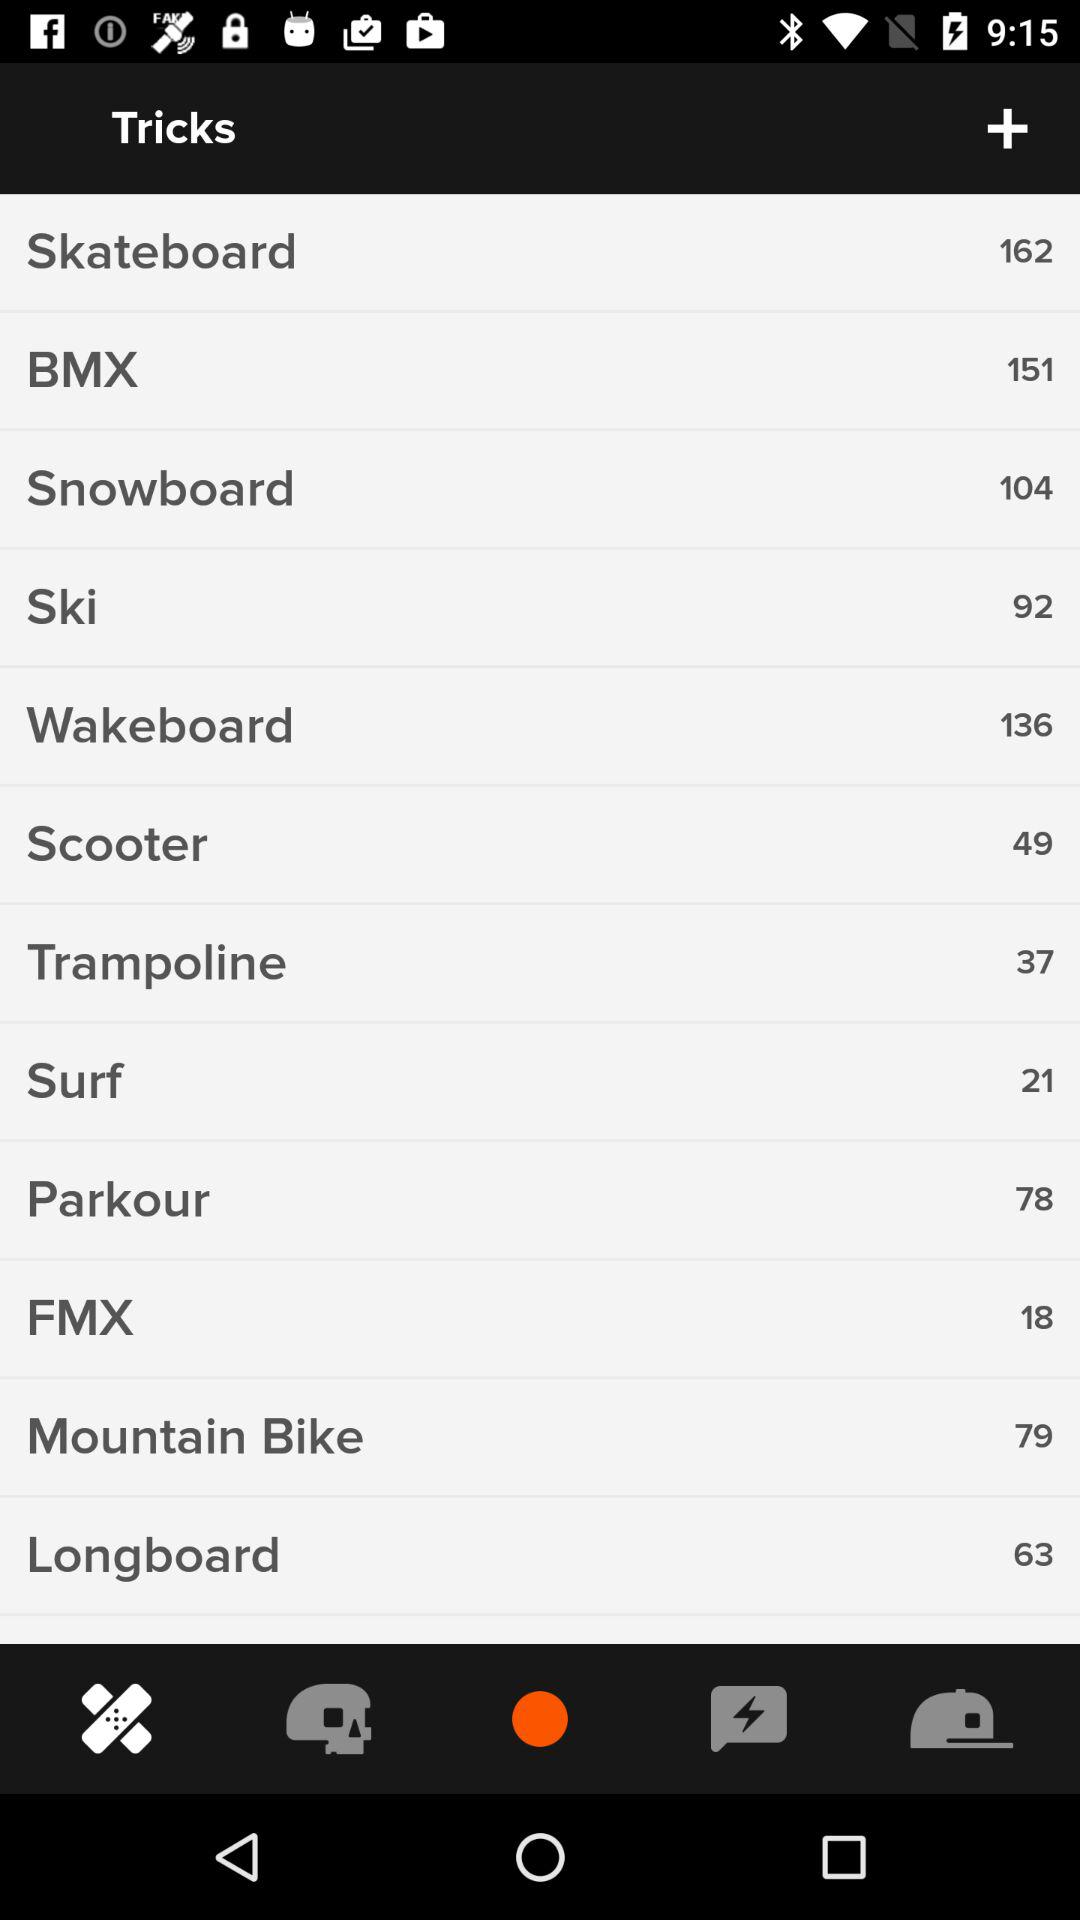What is the BMX number? The BMX number is 151. 